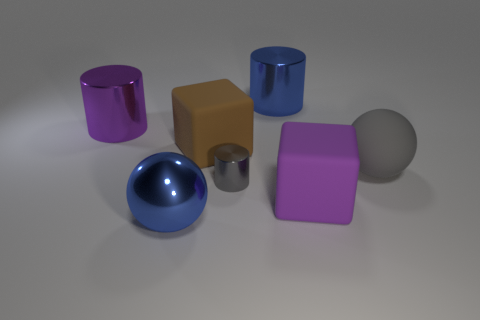There is a big purple matte thing; is it the same shape as the blue metal object behind the brown thing?
Offer a very short reply. No. How many other objects are there of the same material as the gray sphere?
Give a very brief answer. 2. There is a matte block that is on the right side of the large blue object that is behind the large purple thing on the left side of the big brown matte object; what color is it?
Offer a very short reply. Purple. What shape is the object in front of the large purple object to the right of the big brown rubber block?
Your answer should be very brief. Sphere. Is the number of small gray objects that are in front of the purple metal cylinder greater than the number of gray rubber balls?
Your response must be concise. No. Does the big metal object that is in front of the brown object have the same shape as the large gray rubber thing?
Your answer should be compact. Yes. Are there any large gray things that have the same shape as the brown thing?
Make the answer very short. No. How many objects are either big metal things that are behind the big purple cylinder or small gray shiny cylinders?
Keep it short and to the point. 2. Is the number of large brown rubber cubes greater than the number of small green matte objects?
Offer a terse response. Yes. Are there any blue blocks of the same size as the rubber ball?
Offer a terse response. No. 